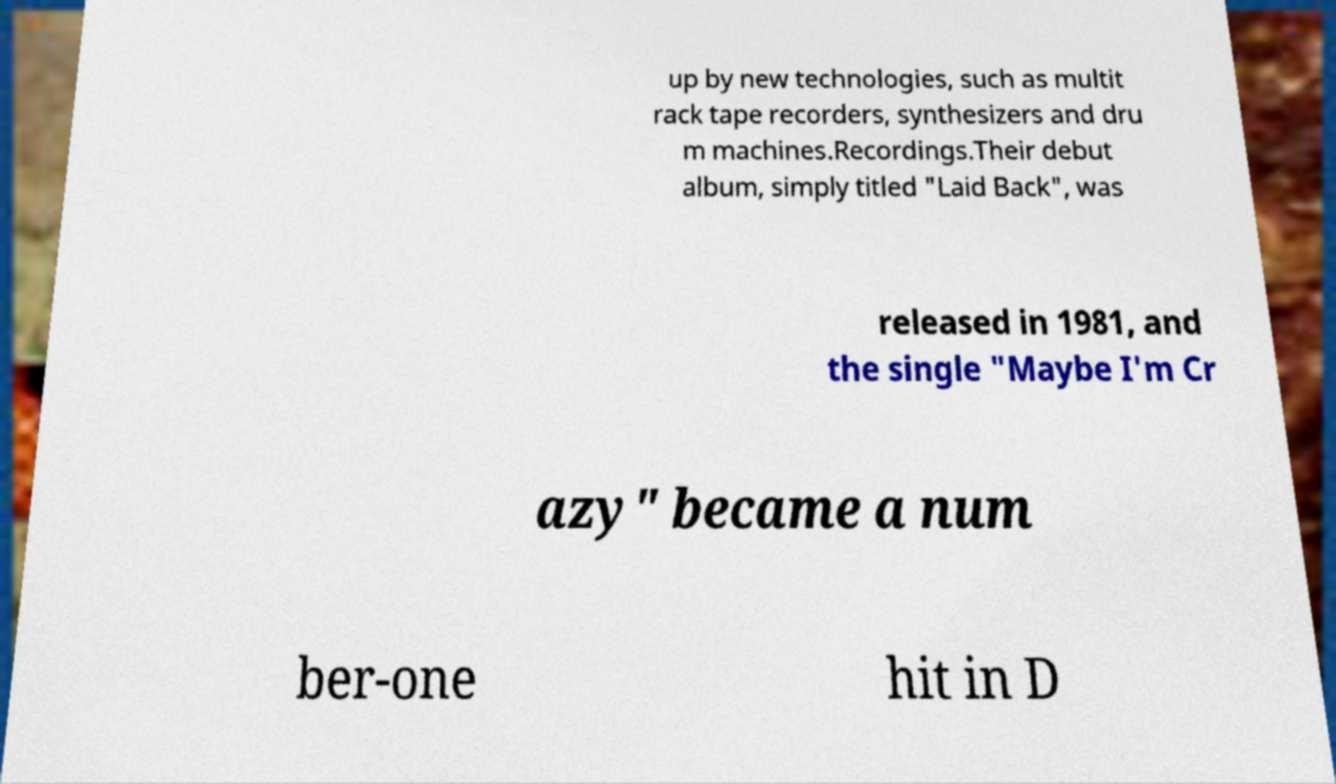I need the written content from this picture converted into text. Can you do that? up by new technologies, such as multit rack tape recorders, synthesizers and dru m machines.Recordings.Their debut album, simply titled "Laid Back", was released in 1981, and the single "Maybe I'm Cr azy" became a num ber-one hit in D 